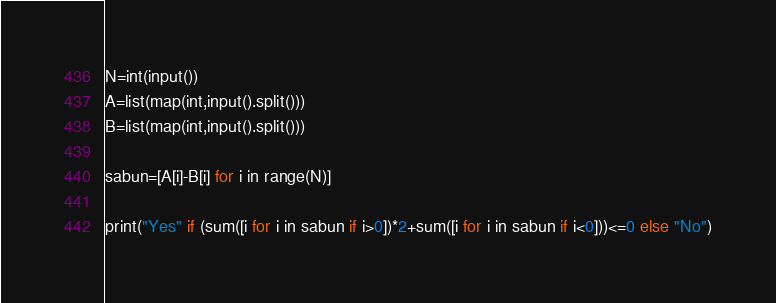Convert code to text. <code><loc_0><loc_0><loc_500><loc_500><_Python_>N=int(input())
A=list(map(int,input().split()))
B=list(map(int,input().split()))

sabun=[A[i]-B[i] for i in range(N)]

print("Yes" if (sum([i for i in sabun if i>0])*2+sum([i for i in sabun if i<0]))<=0 else "No")
</code> 